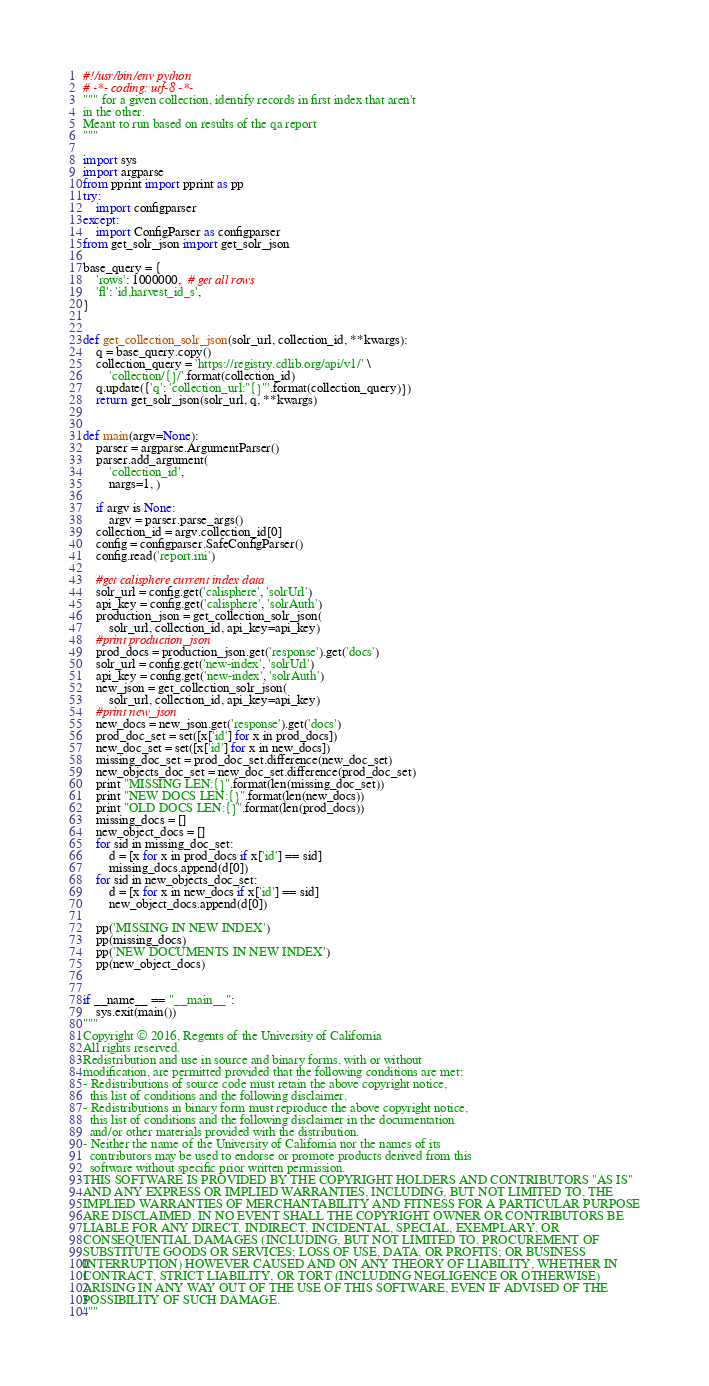Convert code to text. <code><loc_0><loc_0><loc_500><loc_500><_Python_>#!/usr/bin/env python
# -*- coding: utf-8 -*-
""" for a given collection, identify records in first index that aren't
in the other.
Meant to run based on results of the qa report
"""

import sys
import argparse
from pprint import pprint as pp
try:
    import configparser
except:
    import ConfigParser as configparser
from get_solr_json import get_solr_json

base_query = {
    'rows': 1000000,  # get all rows
    'fl': 'id,harvest_id_s',
}


def get_collection_solr_json(solr_url, collection_id, **kwargs):
    q = base_query.copy()
    collection_query = 'https://registry.cdlib.org/api/v1/' \
        'collection/{}/'.format(collection_id)
    q.update({'q': 'collection_url:"{}"'.format(collection_query)})
    return get_solr_json(solr_url, q, **kwargs)


def main(argv=None):
    parser = argparse.ArgumentParser()
    parser.add_argument(
        'collection_id',
        nargs=1, )

    if argv is None:
        argv = parser.parse_args()
    collection_id = argv.collection_id[0]
    config = configparser.SafeConfigParser()
    config.read('report.ini')

    #get calisphere current index data
    solr_url = config.get('calisphere', 'solrUrl')
    api_key = config.get('calisphere', 'solrAuth')
    production_json = get_collection_solr_json(
        solr_url, collection_id, api_key=api_key)
    #print production_json
    prod_docs = production_json.get('response').get('docs')
    solr_url = config.get('new-index', 'solrUrl')
    api_key = config.get('new-index', 'solrAuth')
    new_json = get_collection_solr_json(
        solr_url, collection_id, api_key=api_key)
    #print new_json
    new_docs = new_json.get('response').get('docs')
    prod_doc_set = set([x['id'] for x in prod_docs])
    new_doc_set = set([x['id'] for x in new_docs])
    missing_doc_set = prod_doc_set.difference(new_doc_set)
    new_objects_doc_set = new_doc_set.difference(prod_doc_set)
    print "MISSING LEN:{}".format(len(missing_doc_set))
    print "NEW DOCS LEN:{}".format(len(new_docs))
    print "OLD DOCS LEN:{}".format(len(prod_docs))
    missing_docs = []
    new_object_docs = []
    for sid in missing_doc_set:
        d = [x for x in prod_docs if x['id'] == sid]
        missing_docs.append(d[0])
    for sid in new_objects_doc_set:
        d = [x for x in new_docs if x['id'] == sid]
        new_object_docs.append(d[0])

    pp('MISSING IN NEW INDEX')
    pp(missing_docs)
    pp('NEW DOCUMENTS IN NEW INDEX')
    pp(new_object_docs)


if __name__ == "__main__":
    sys.exit(main())
"""
Copyright © 2016, Regents of the University of California
All rights reserved.
Redistribution and use in source and binary forms, with or without
modification, are permitted provided that the following conditions are met:
- Redistributions of source code must retain the above copyright notice,
  this list of conditions and the following disclaimer.
- Redistributions in binary form must reproduce the above copyright notice,
  this list of conditions and the following disclaimer in the documentation
  and/or other materials provided with the distribution.
- Neither the name of the University of California nor the names of its
  contributors may be used to endorse or promote products derived from this
  software without specific prior written permission.
THIS SOFTWARE IS PROVIDED BY THE COPYRIGHT HOLDERS AND CONTRIBUTORS "AS IS"
AND ANY EXPRESS OR IMPLIED WARRANTIES, INCLUDING, BUT NOT LIMITED TO, THE
IMPLIED WARRANTIES OF MERCHANTABILITY AND FITNESS FOR A PARTICULAR PURPOSE
ARE DISCLAIMED. IN NO EVENT SHALL THE COPYRIGHT OWNER OR CONTRIBUTORS BE
LIABLE FOR ANY DIRECT, INDIRECT, INCIDENTAL, SPECIAL, EXEMPLARY, OR
CONSEQUENTIAL DAMAGES (INCLUDING, BUT NOT LIMITED TO, PROCUREMENT OF
SUBSTITUTE GOODS OR SERVICES; LOSS OF USE, DATA, OR PROFITS; OR BUSINESS
INTERRUPTION) HOWEVER CAUSED AND ON ANY THEORY OF LIABILITY, WHETHER IN
CONTRACT, STRICT LIABILITY, OR TORT (INCLUDING NEGLIGENCE OR OTHERWISE)
ARISING IN ANY WAY OUT OF THE USE OF THIS SOFTWARE, EVEN IF ADVISED OF THE
POSSIBILITY OF SUCH DAMAGE.
"""
</code> 